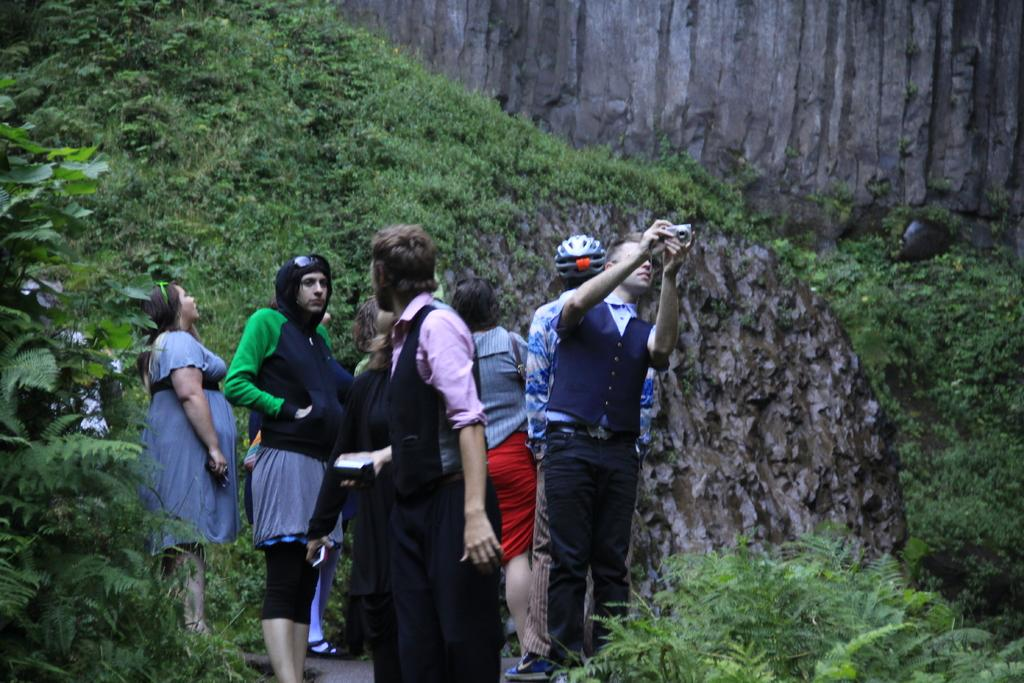What is the main subject of the image? The main subject of the image is a group of people standing. What type of landscape can be seen in the image? The image appears to depict a hill. What type of vegetation is present in the image? There are trees and plants in the image. What color are the trees and plants in the image? The trees and plants are green in color. How many limits can be seen in the image? There are no limits visible in the image. What type of tin is being used by the people in the image? There is no tin present in the image; it only shows a group of people standing on a hill with trees and plants. 